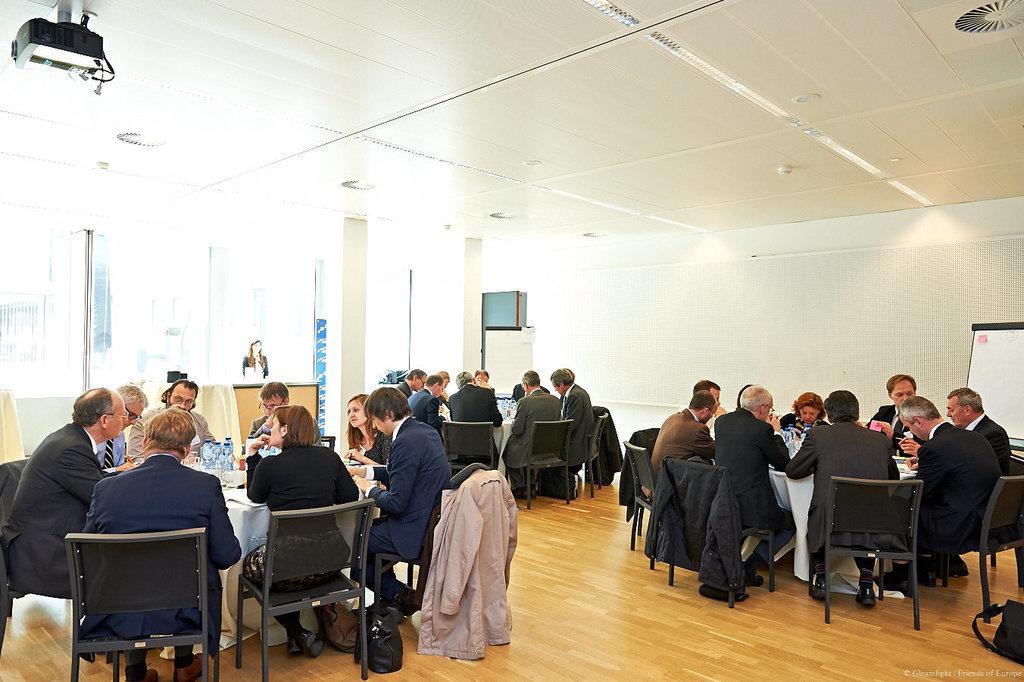Describe this image in one or two sentences. It is a conference room, there are three tables and many chairs around the tables and lot of people are sitting , in between these there is another table where a woman is standing in front of it. To the roof there is a projector in the background there is a lot of sunlight and glasses. 